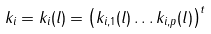<formula> <loc_0><loc_0><loc_500><loc_500>k _ { i } = k _ { i } ( l ) = \left ( k _ { i , 1 } ( l ) \dots k _ { i , p } ( l ) \right ) ^ { t }</formula> 